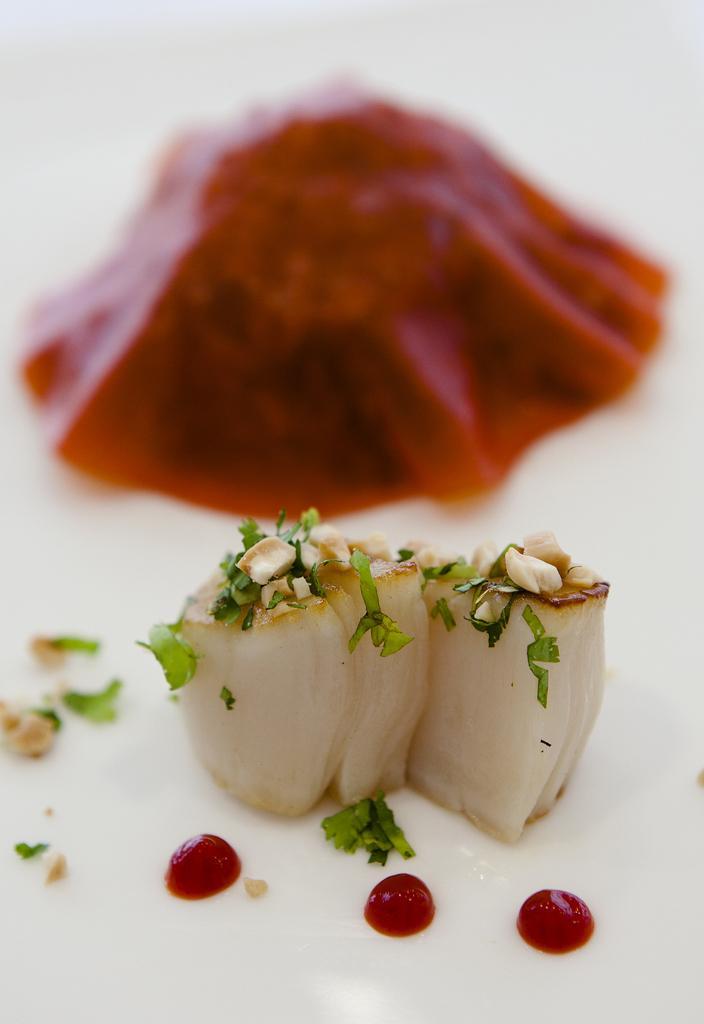How would you summarize this image in a sentence or two? In the foreground of the picture there is a food item. In the background there is a red color object and it is not clear. 